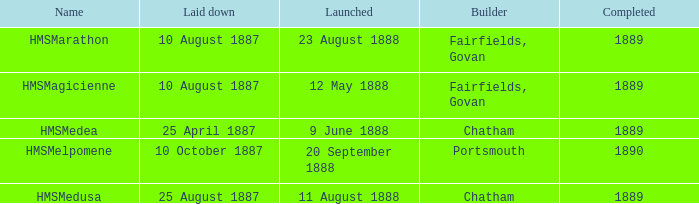Which builder completed before 1890 and launched on 9 june 1888? Chatham. 